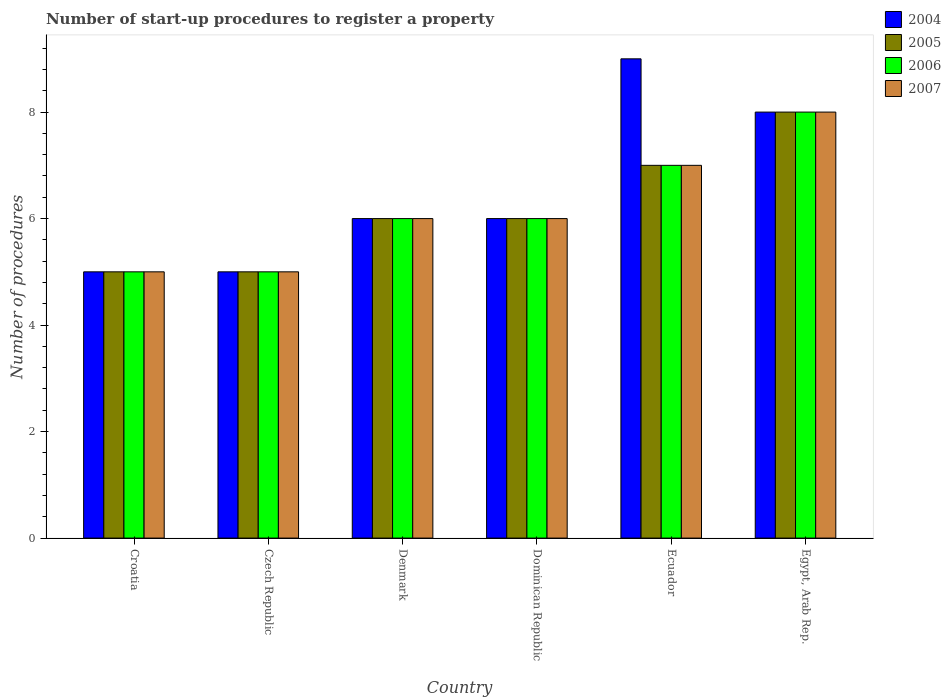How many different coloured bars are there?
Your answer should be very brief. 4. Are the number of bars per tick equal to the number of legend labels?
Provide a short and direct response. Yes. How many bars are there on the 1st tick from the left?
Ensure brevity in your answer.  4. What is the label of the 2nd group of bars from the left?
Keep it short and to the point. Czech Republic. In how many cases, is the number of bars for a given country not equal to the number of legend labels?
Your response must be concise. 0. Across all countries, what is the maximum number of procedures required to register a property in 2004?
Your answer should be very brief. 9. Across all countries, what is the minimum number of procedures required to register a property in 2005?
Your response must be concise. 5. In which country was the number of procedures required to register a property in 2007 maximum?
Keep it short and to the point. Egypt, Arab Rep. In which country was the number of procedures required to register a property in 2004 minimum?
Offer a very short reply. Croatia. What is the total number of procedures required to register a property in 2007 in the graph?
Keep it short and to the point. 37. What is the difference between the number of procedures required to register a property in 2004 in Czech Republic and that in Egypt, Arab Rep.?
Your answer should be very brief. -3. What is the average number of procedures required to register a property in 2005 per country?
Ensure brevity in your answer.  6.17. What is the difference between the number of procedures required to register a property of/in 2005 and number of procedures required to register a property of/in 2004 in Ecuador?
Make the answer very short. -2. What is the ratio of the number of procedures required to register a property in 2006 in Denmark to that in Dominican Republic?
Give a very brief answer. 1. Is the difference between the number of procedures required to register a property in 2005 in Croatia and Ecuador greater than the difference between the number of procedures required to register a property in 2004 in Croatia and Ecuador?
Your answer should be compact. Yes. What is the difference between the highest and the second highest number of procedures required to register a property in 2004?
Make the answer very short. -1. What is the difference between the highest and the lowest number of procedures required to register a property in 2006?
Provide a succinct answer. 3. Is it the case that in every country, the sum of the number of procedures required to register a property in 2005 and number of procedures required to register a property in 2007 is greater than the sum of number of procedures required to register a property in 2004 and number of procedures required to register a property in 2006?
Make the answer very short. No. Is it the case that in every country, the sum of the number of procedures required to register a property in 2006 and number of procedures required to register a property in 2005 is greater than the number of procedures required to register a property in 2007?
Your answer should be compact. Yes. Are all the bars in the graph horizontal?
Give a very brief answer. No. What is the difference between two consecutive major ticks on the Y-axis?
Your answer should be compact. 2. Does the graph contain any zero values?
Your answer should be compact. No. Where does the legend appear in the graph?
Your answer should be very brief. Top right. How many legend labels are there?
Make the answer very short. 4. What is the title of the graph?
Offer a terse response. Number of start-up procedures to register a property. What is the label or title of the X-axis?
Keep it short and to the point. Country. What is the label or title of the Y-axis?
Make the answer very short. Number of procedures. What is the Number of procedures in 2006 in Croatia?
Provide a short and direct response. 5. What is the Number of procedures of 2007 in Croatia?
Your answer should be very brief. 5. What is the Number of procedures of 2006 in Czech Republic?
Your response must be concise. 5. What is the Number of procedures in 2004 in Denmark?
Make the answer very short. 6. What is the Number of procedures in 2005 in Denmark?
Ensure brevity in your answer.  6. What is the Number of procedures in 2006 in Denmark?
Provide a short and direct response. 6. What is the Number of procedures of 2006 in Ecuador?
Provide a short and direct response. 7. What is the Number of procedures in 2004 in Egypt, Arab Rep.?
Your answer should be very brief. 8. What is the Number of procedures of 2005 in Egypt, Arab Rep.?
Your answer should be very brief. 8. Across all countries, what is the maximum Number of procedures in 2006?
Keep it short and to the point. 8. Across all countries, what is the minimum Number of procedures in 2004?
Keep it short and to the point. 5. Across all countries, what is the minimum Number of procedures in 2006?
Provide a short and direct response. 5. Across all countries, what is the minimum Number of procedures of 2007?
Offer a very short reply. 5. What is the total Number of procedures of 2004 in the graph?
Offer a very short reply. 39. What is the total Number of procedures of 2005 in the graph?
Your answer should be compact. 37. What is the difference between the Number of procedures of 2004 in Croatia and that in Czech Republic?
Give a very brief answer. 0. What is the difference between the Number of procedures in 2006 in Croatia and that in Czech Republic?
Your response must be concise. 0. What is the difference between the Number of procedures of 2006 in Croatia and that in Denmark?
Keep it short and to the point. -1. What is the difference between the Number of procedures in 2007 in Croatia and that in Denmark?
Keep it short and to the point. -1. What is the difference between the Number of procedures in 2006 in Croatia and that in Dominican Republic?
Provide a succinct answer. -1. What is the difference between the Number of procedures of 2005 in Croatia and that in Ecuador?
Your answer should be very brief. -2. What is the difference between the Number of procedures in 2006 in Croatia and that in Ecuador?
Offer a very short reply. -2. What is the difference between the Number of procedures of 2007 in Croatia and that in Ecuador?
Your response must be concise. -2. What is the difference between the Number of procedures of 2004 in Croatia and that in Egypt, Arab Rep.?
Keep it short and to the point. -3. What is the difference between the Number of procedures in 2005 in Croatia and that in Egypt, Arab Rep.?
Your answer should be compact. -3. What is the difference between the Number of procedures in 2006 in Croatia and that in Egypt, Arab Rep.?
Your response must be concise. -3. What is the difference between the Number of procedures in 2007 in Czech Republic and that in Denmark?
Provide a short and direct response. -1. What is the difference between the Number of procedures of 2004 in Czech Republic and that in Dominican Republic?
Give a very brief answer. -1. What is the difference between the Number of procedures of 2006 in Czech Republic and that in Dominican Republic?
Your answer should be very brief. -1. What is the difference between the Number of procedures of 2007 in Czech Republic and that in Dominican Republic?
Ensure brevity in your answer.  -1. What is the difference between the Number of procedures in 2004 in Czech Republic and that in Ecuador?
Ensure brevity in your answer.  -4. What is the difference between the Number of procedures of 2005 in Czech Republic and that in Ecuador?
Offer a very short reply. -2. What is the difference between the Number of procedures of 2006 in Czech Republic and that in Ecuador?
Your answer should be compact. -2. What is the difference between the Number of procedures in 2004 in Czech Republic and that in Egypt, Arab Rep.?
Ensure brevity in your answer.  -3. What is the difference between the Number of procedures of 2005 in Czech Republic and that in Egypt, Arab Rep.?
Provide a succinct answer. -3. What is the difference between the Number of procedures in 2007 in Czech Republic and that in Egypt, Arab Rep.?
Offer a very short reply. -3. What is the difference between the Number of procedures in 2004 in Denmark and that in Ecuador?
Make the answer very short. -3. What is the difference between the Number of procedures of 2005 in Denmark and that in Ecuador?
Give a very brief answer. -1. What is the difference between the Number of procedures of 2007 in Denmark and that in Ecuador?
Give a very brief answer. -1. What is the difference between the Number of procedures of 2004 in Denmark and that in Egypt, Arab Rep.?
Offer a very short reply. -2. What is the difference between the Number of procedures in 2005 in Denmark and that in Egypt, Arab Rep.?
Offer a very short reply. -2. What is the difference between the Number of procedures of 2005 in Dominican Republic and that in Ecuador?
Provide a short and direct response. -1. What is the difference between the Number of procedures of 2004 in Dominican Republic and that in Egypt, Arab Rep.?
Your answer should be very brief. -2. What is the difference between the Number of procedures of 2005 in Dominican Republic and that in Egypt, Arab Rep.?
Offer a very short reply. -2. What is the difference between the Number of procedures in 2006 in Dominican Republic and that in Egypt, Arab Rep.?
Provide a short and direct response. -2. What is the difference between the Number of procedures in 2007 in Dominican Republic and that in Egypt, Arab Rep.?
Provide a short and direct response. -2. What is the difference between the Number of procedures of 2004 in Ecuador and that in Egypt, Arab Rep.?
Provide a succinct answer. 1. What is the difference between the Number of procedures in 2005 in Ecuador and that in Egypt, Arab Rep.?
Offer a terse response. -1. What is the difference between the Number of procedures in 2006 in Ecuador and that in Egypt, Arab Rep.?
Your response must be concise. -1. What is the difference between the Number of procedures in 2004 in Croatia and the Number of procedures in 2006 in Czech Republic?
Your answer should be compact. 0. What is the difference between the Number of procedures of 2004 in Croatia and the Number of procedures of 2007 in Czech Republic?
Provide a short and direct response. 0. What is the difference between the Number of procedures of 2005 in Croatia and the Number of procedures of 2006 in Czech Republic?
Your response must be concise. 0. What is the difference between the Number of procedures in 2005 in Croatia and the Number of procedures in 2007 in Czech Republic?
Make the answer very short. 0. What is the difference between the Number of procedures of 2006 in Croatia and the Number of procedures of 2007 in Czech Republic?
Provide a short and direct response. 0. What is the difference between the Number of procedures of 2004 in Croatia and the Number of procedures of 2005 in Denmark?
Your response must be concise. -1. What is the difference between the Number of procedures in 2004 in Croatia and the Number of procedures in 2007 in Denmark?
Make the answer very short. -1. What is the difference between the Number of procedures of 2004 in Croatia and the Number of procedures of 2007 in Ecuador?
Keep it short and to the point. -2. What is the difference between the Number of procedures of 2005 in Croatia and the Number of procedures of 2006 in Ecuador?
Make the answer very short. -2. What is the difference between the Number of procedures of 2004 in Croatia and the Number of procedures of 2005 in Egypt, Arab Rep.?
Provide a short and direct response. -3. What is the difference between the Number of procedures of 2004 in Croatia and the Number of procedures of 2006 in Egypt, Arab Rep.?
Your answer should be very brief. -3. What is the difference between the Number of procedures of 2005 in Croatia and the Number of procedures of 2006 in Egypt, Arab Rep.?
Make the answer very short. -3. What is the difference between the Number of procedures of 2004 in Czech Republic and the Number of procedures of 2005 in Denmark?
Your answer should be compact. -1. What is the difference between the Number of procedures of 2004 in Czech Republic and the Number of procedures of 2006 in Denmark?
Make the answer very short. -1. What is the difference between the Number of procedures of 2004 in Czech Republic and the Number of procedures of 2007 in Denmark?
Make the answer very short. -1. What is the difference between the Number of procedures of 2005 in Czech Republic and the Number of procedures of 2006 in Denmark?
Your response must be concise. -1. What is the difference between the Number of procedures of 2006 in Czech Republic and the Number of procedures of 2007 in Denmark?
Your response must be concise. -1. What is the difference between the Number of procedures in 2005 in Czech Republic and the Number of procedures in 2006 in Dominican Republic?
Your response must be concise. -1. What is the difference between the Number of procedures of 2004 in Czech Republic and the Number of procedures of 2006 in Ecuador?
Your response must be concise. -2. What is the difference between the Number of procedures in 2005 in Czech Republic and the Number of procedures in 2007 in Ecuador?
Offer a terse response. -2. What is the difference between the Number of procedures in 2004 in Czech Republic and the Number of procedures in 2005 in Egypt, Arab Rep.?
Offer a terse response. -3. What is the difference between the Number of procedures of 2005 in Czech Republic and the Number of procedures of 2006 in Egypt, Arab Rep.?
Give a very brief answer. -3. What is the difference between the Number of procedures of 2004 in Denmark and the Number of procedures of 2005 in Dominican Republic?
Make the answer very short. 0. What is the difference between the Number of procedures in 2004 in Denmark and the Number of procedures in 2006 in Dominican Republic?
Your response must be concise. 0. What is the difference between the Number of procedures of 2004 in Denmark and the Number of procedures of 2007 in Dominican Republic?
Offer a terse response. 0. What is the difference between the Number of procedures of 2005 in Denmark and the Number of procedures of 2006 in Dominican Republic?
Keep it short and to the point. 0. What is the difference between the Number of procedures in 2005 in Denmark and the Number of procedures in 2007 in Dominican Republic?
Give a very brief answer. 0. What is the difference between the Number of procedures of 2006 in Denmark and the Number of procedures of 2007 in Dominican Republic?
Give a very brief answer. 0. What is the difference between the Number of procedures in 2004 in Denmark and the Number of procedures in 2007 in Ecuador?
Offer a terse response. -1. What is the difference between the Number of procedures of 2005 in Denmark and the Number of procedures of 2006 in Ecuador?
Offer a very short reply. -1. What is the difference between the Number of procedures of 2005 in Denmark and the Number of procedures of 2007 in Ecuador?
Provide a short and direct response. -1. What is the difference between the Number of procedures in 2004 in Denmark and the Number of procedures in 2006 in Egypt, Arab Rep.?
Keep it short and to the point. -2. What is the difference between the Number of procedures of 2005 in Denmark and the Number of procedures of 2006 in Egypt, Arab Rep.?
Give a very brief answer. -2. What is the difference between the Number of procedures in 2006 in Denmark and the Number of procedures in 2007 in Egypt, Arab Rep.?
Ensure brevity in your answer.  -2. What is the difference between the Number of procedures in 2005 in Dominican Republic and the Number of procedures in 2006 in Ecuador?
Ensure brevity in your answer.  -1. What is the difference between the Number of procedures of 2005 in Dominican Republic and the Number of procedures of 2007 in Ecuador?
Give a very brief answer. -1. What is the difference between the Number of procedures in 2004 in Dominican Republic and the Number of procedures in 2005 in Egypt, Arab Rep.?
Your answer should be very brief. -2. What is the difference between the Number of procedures of 2005 in Dominican Republic and the Number of procedures of 2006 in Egypt, Arab Rep.?
Give a very brief answer. -2. What is the difference between the Number of procedures in 2005 in Ecuador and the Number of procedures in 2006 in Egypt, Arab Rep.?
Offer a terse response. -1. What is the difference between the Number of procedures in 2005 in Ecuador and the Number of procedures in 2007 in Egypt, Arab Rep.?
Offer a terse response. -1. What is the average Number of procedures of 2005 per country?
Your response must be concise. 6.17. What is the average Number of procedures in 2006 per country?
Offer a terse response. 6.17. What is the average Number of procedures of 2007 per country?
Offer a terse response. 6.17. What is the difference between the Number of procedures in 2005 and Number of procedures in 2007 in Croatia?
Give a very brief answer. 0. What is the difference between the Number of procedures in 2004 and Number of procedures in 2005 in Czech Republic?
Keep it short and to the point. 0. What is the difference between the Number of procedures in 2005 and Number of procedures in 2006 in Czech Republic?
Your answer should be very brief. 0. What is the difference between the Number of procedures in 2005 and Number of procedures in 2007 in Czech Republic?
Make the answer very short. 0. What is the difference between the Number of procedures in 2006 and Number of procedures in 2007 in Czech Republic?
Make the answer very short. 0. What is the difference between the Number of procedures of 2005 and Number of procedures of 2007 in Denmark?
Provide a short and direct response. 0. What is the difference between the Number of procedures in 2004 and Number of procedures in 2005 in Dominican Republic?
Provide a succinct answer. 0. What is the difference between the Number of procedures of 2004 and Number of procedures of 2006 in Dominican Republic?
Offer a very short reply. 0. What is the difference between the Number of procedures of 2005 and Number of procedures of 2007 in Dominican Republic?
Make the answer very short. 0. What is the difference between the Number of procedures in 2004 and Number of procedures in 2005 in Ecuador?
Provide a succinct answer. 2. What is the difference between the Number of procedures in 2004 and Number of procedures in 2006 in Ecuador?
Give a very brief answer. 2. What is the difference between the Number of procedures in 2004 and Number of procedures in 2007 in Ecuador?
Give a very brief answer. 2. What is the difference between the Number of procedures of 2005 and Number of procedures of 2006 in Ecuador?
Make the answer very short. 0. What is the difference between the Number of procedures of 2006 and Number of procedures of 2007 in Ecuador?
Ensure brevity in your answer.  0. What is the difference between the Number of procedures of 2004 and Number of procedures of 2005 in Egypt, Arab Rep.?
Provide a succinct answer. 0. What is the difference between the Number of procedures in 2004 and Number of procedures in 2007 in Egypt, Arab Rep.?
Offer a terse response. 0. What is the difference between the Number of procedures in 2005 and Number of procedures in 2007 in Egypt, Arab Rep.?
Provide a short and direct response. 0. What is the ratio of the Number of procedures of 2005 in Croatia to that in Czech Republic?
Give a very brief answer. 1. What is the ratio of the Number of procedures in 2004 in Croatia to that in Denmark?
Keep it short and to the point. 0.83. What is the ratio of the Number of procedures of 2005 in Croatia to that in Denmark?
Your answer should be compact. 0.83. What is the ratio of the Number of procedures in 2006 in Croatia to that in Denmark?
Give a very brief answer. 0.83. What is the ratio of the Number of procedures of 2007 in Croatia to that in Denmark?
Give a very brief answer. 0.83. What is the ratio of the Number of procedures of 2004 in Croatia to that in Dominican Republic?
Make the answer very short. 0.83. What is the ratio of the Number of procedures in 2005 in Croatia to that in Dominican Republic?
Offer a terse response. 0.83. What is the ratio of the Number of procedures of 2006 in Croatia to that in Dominican Republic?
Your answer should be very brief. 0.83. What is the ratio of the Number of procedures in 2004 in Croatia to that in Ecuador?
Offer a very short reply. 0.56. What is the ratio of the Number of procedures in 2006 in Croatia to that in Ecuador?
Make the answer very short. 0.71. What is the ratio of the Number of procedures in 2007 in Croatia to that in Ecuador?
Give a very brief answer. 0.71. What is the ratio of the Number of procedures of 2004 in Croatia to that in Egypt, Arab Rep.?
Offer a very short reply. 0.62. What is the ratio of the Number of procedures in 2006 in Croatia to that in Egypt, Arab Rep.?
Give a very brief answer. 0.62. What is the ratio of the Number of procedures of 2007 in Croatia to that in Egypt, Arab Rep.?
Keep it short and to the point. 0.62. What is the ratio of the Number of procedures of 2005 in Czech Republic to that in Denmark?
Your answer should be compact. 0.83. What is the ratio of the Number of procedures of 2006 in Czech Republic to that in Denmark?
Your response must be concise. 0.83. What is the ratio of the Number of procedures of 2007 in Czech Republic to that in Denmark?
Your answer should be very brief. 0.83. What is the ratio of the Number of procedures of 2006 in Czech Republic to that in Dominican Republic?
Your response must be concise. 0.83. What is the ratio of the Number of procedures of 2007 in Czech Republic to that in Dominican Republic?
Offer a terse response. 0.83. What is the ratio of the Number of procedures of 2004 in Czech Republic to that in Ecuador?
Ensure brevity in your answer.  0.56. What is the ratio of the Number of procedures of 2004 in Czech Republic to that in Egypt, Arab Rep.?
Your answer should be compact. 0.62. What is the ratio of the Number of procedures in 2005 in Czech Republic to that in Egypt, Arab Rep.?
Make the answer very short. 0.62. What is the ratio of the Number of procedures of 2007 in Czech Republic to that in Egypt, Arab Rep.?
Offer a very short reply. 0.62. What is the ratio of the Number of procedures of 2004 in Denmark to that in Dominican Republic?
Offer a terse response. 1. What is the ratio of the Number of procedures of 2005 in Denmark to that in Dominican Republic?
Offer a terse response. 1. What is the ratio of the Number of procedures of 2004 in Denmark to that in Ecuador?
Provide a succinct answer. 0.67. What is the ratio of the Number of procedures of 2005 in Denmark to that in Ecuador?
Ensure brevity in your answer.  0.86. What is the ratio of the Number of procedures of 2006 in Denmark to that in Ecuador?
Keep it short and to the point. 0.86. What is the ratio of the Number of procedures of 2004 in Denmark to that in Egypt, Arab Rep.?
Your answer should be very brief. 0.75. What is the ratio of the Number of procedures in 2007 in Denmark to that in Egypt, Arab Rep.?
Your response must be concise. 0.75. What is the ratio of the Number of procedures of 2004 in Dominican Republic to that in Ecuador?
Offer a very short reply. 0.67. What is the ratio of the Number of procedures in 2005 in Dominican Republic to that in Ecuador?
Make the answer very short. 0.86. What is the ratio of the Number of procedures of 2006 in Dominican Republic to that in Ecuador?
Provide a short and direct response. 0.86. What is the ratio of the Number of procedures in 2007 in Dominican Republic to that in Ecuador?
Give a very brief answer. 0.86. What is the ratio of the Number of procedures of 2007 in Dominican Republic to that in Egypt, Arab Rep.?
Your answer should be compact. 0.75. What is the ratio of the Number of procedures of 2006 in Ecuador to that in Egypt, Arab Rep.?
Your answer should be compact. 0.88. What is the difference between the highest and the second highest Number of procedures of 2007?
Your answer should be compact. 1. What is the difference between the highest and the lowest Number of procedures of 2004?
Provide a short and direct response. 4. 